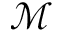<formula> <loc_0><loc_0><loc_500><loc_500>\mathcal { M }</formula> 